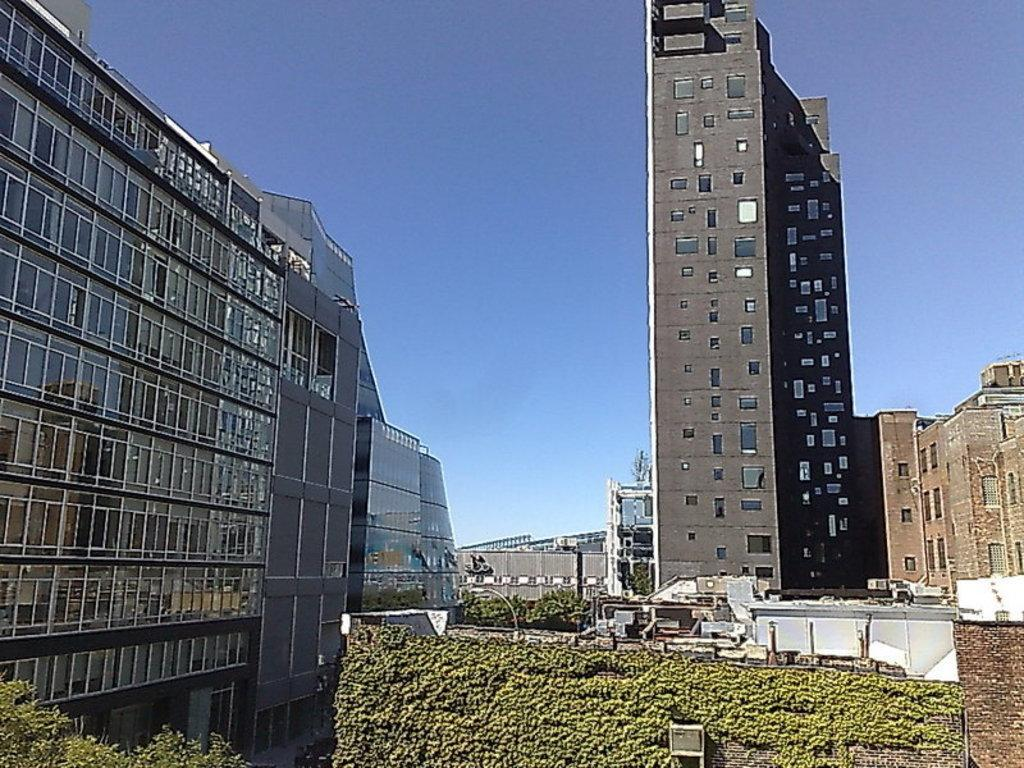What type of structures can be seen in the image? There are buildings in the image. What natural elements are present in the image? There are trees in the image. What man-made objects can be seen in the image? There are poles in the image. What type of vegetation is on a wall in the image? There are plants on a wall in the image. What color is the object that stands out in the image? There is a white-colored object in the image. What part of the natural environment is visible in the image? The sky is visible in the image. What year is depicted in the image? The image does not depict a specific year; it is a static representation of the scene. How many police officers are visible in the image? There are no police officers present in the image. 